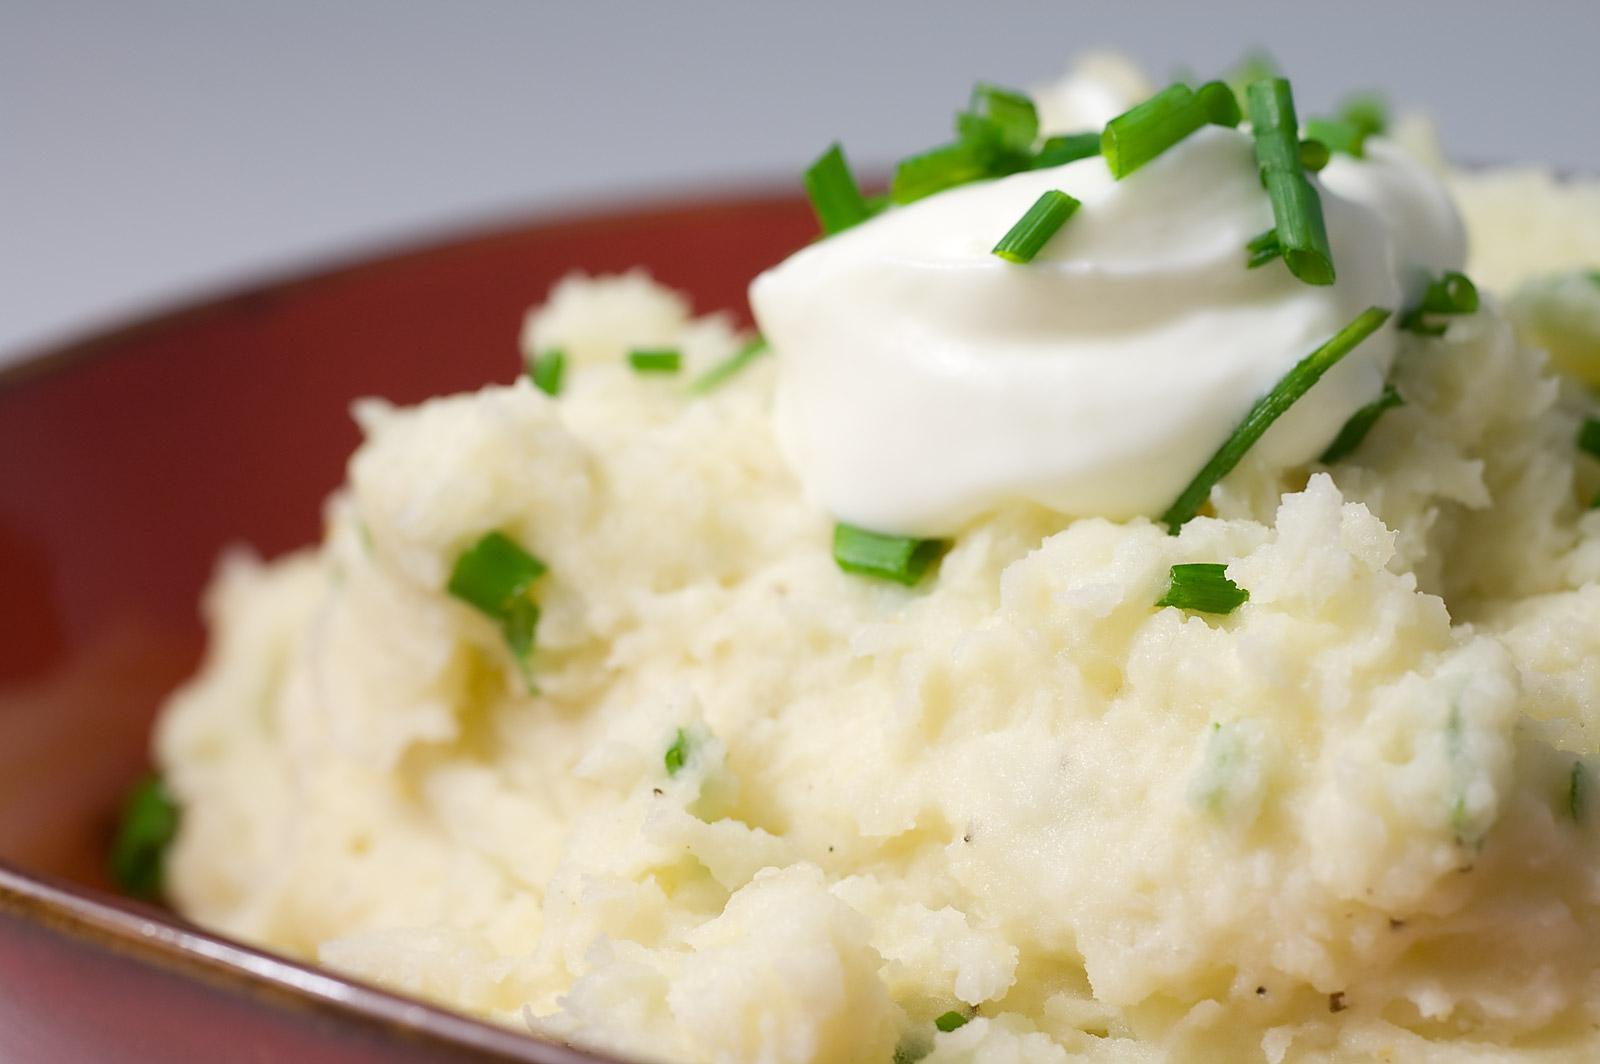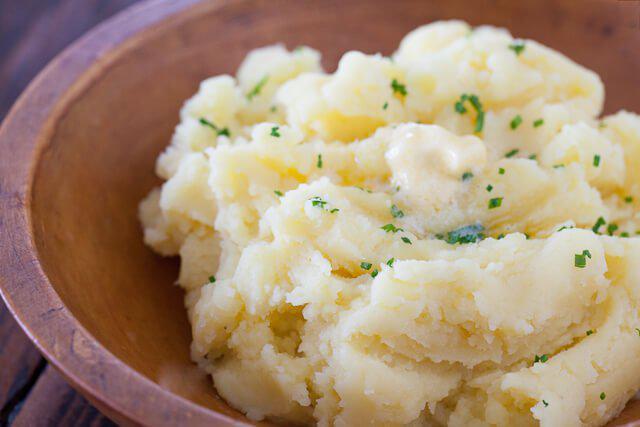The first image is the image on the left, the second image is the image on the right. Considering the images on both sides, is "One image shows two servings of mashed potatoes in purple bowls." valid? Answer yes or no. No. The first image is the image on the left, the second image is the image on the right. Assess this claim about the two images: "There are two bowls of potatoes in one of the images.". Correct or not? Answer yes or no. No. 